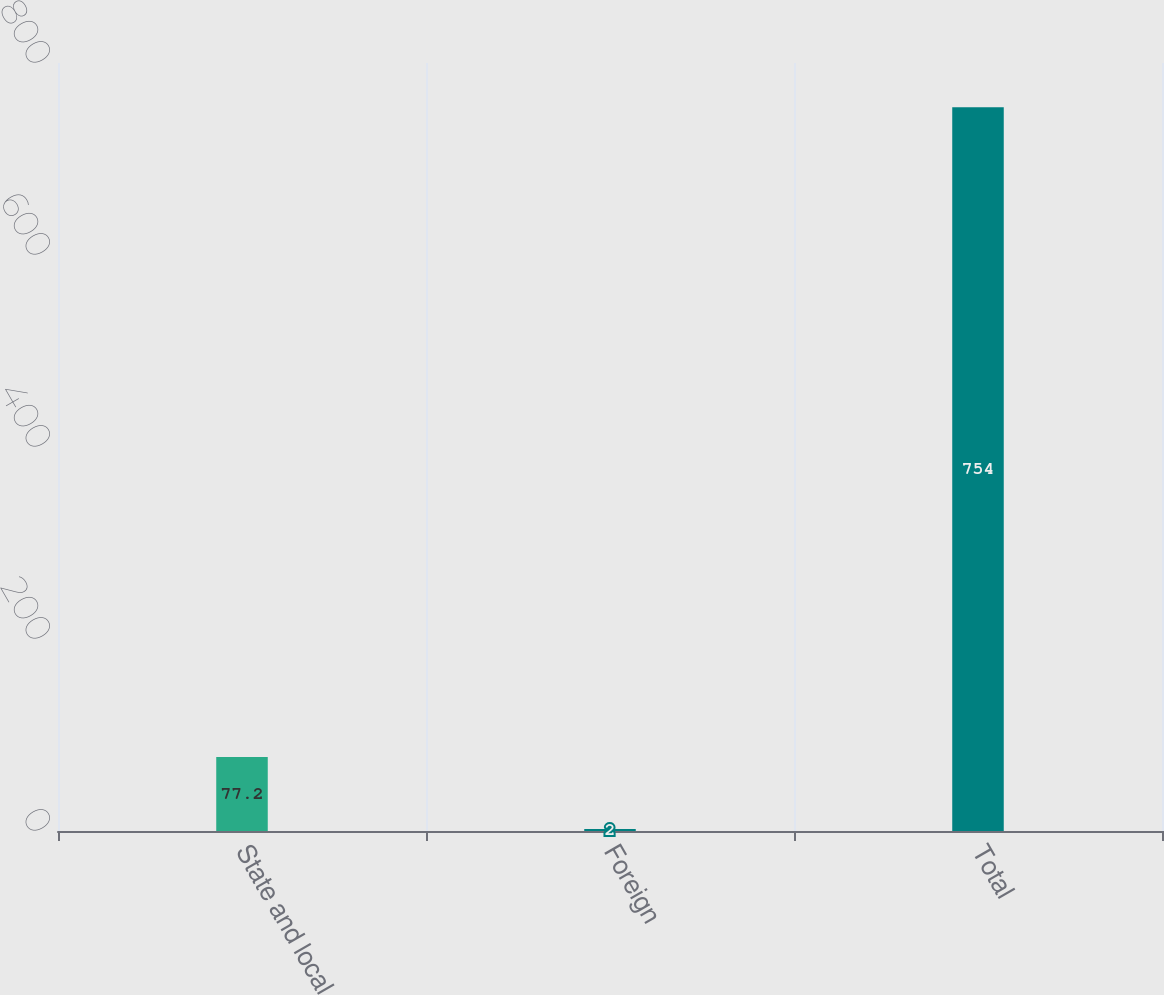<chart> <loc_0><loc_0><loc_500><loc_500><bar_chart><fcel>State and local<fcel>Foreign<fcel>Total<nl><fcel>77.2<fcel>2<fcel>754<nl></chart> 